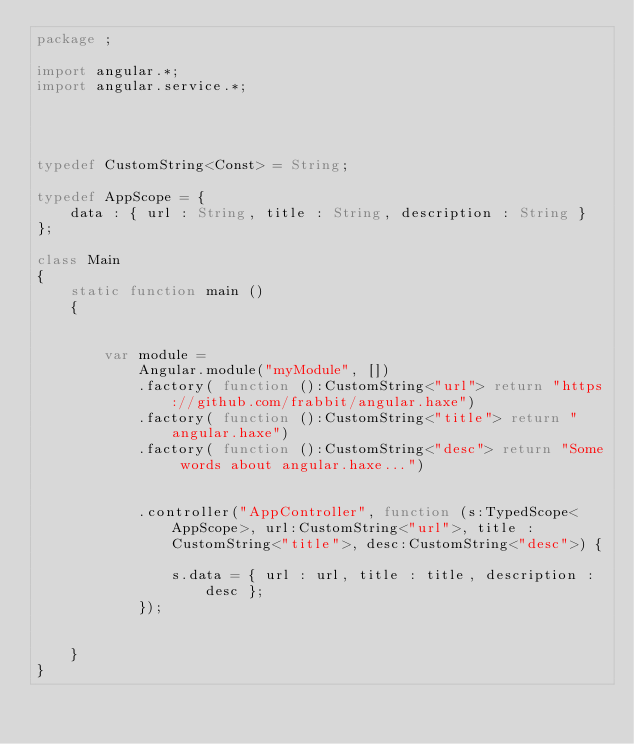Convert code to text. <code><loc_0><loc_0><loc_500><loc_500><_Haxe_>package ;

import angular.*;
import angular.service.*;




typedef CustomString<Const> = String;

typedef AppScope = {
	data : { url : String, title : String, description : String }
};

class Main
{
	static function main ()
	{


		var module =
			Angular.module("myModule", [])
			.factory( function ():CustomString<"url"> return "https://github.com/frabbit/angular.haxe")
			.factory( function ():CustomString<"title"> return "angular.haxe")
			.factory( function ():CustomString<"desc"> return "Some words about angular.haxe...")


			.controller("AppController", function (s:TypedScope<AppScope>, url:CustomString<"url">, title : CustomString<"title">, desc:CustomString<"desc">) {

				s.data = { url : url, title : title, description : desc };
			});


	}
}</code> 